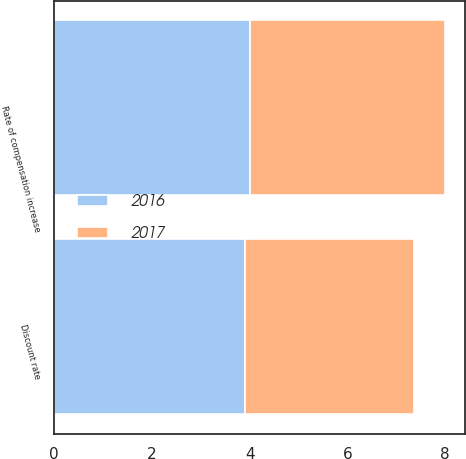Convert chart. <chart><loc_0><loc_0><loc_500><loc_500><stacked_bar_chart><ecel><fcel>Discount rate<fcel>Rate of compensation increase<nl><fcel>2017<fcel>3.46<fcel>4<nl><fcel>2016<fcel>3.91<fcel>4<nl></chart> 